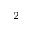<formula> <loc_0><loc_0><loc_500><loc_500>^ { 2 }</formula> 